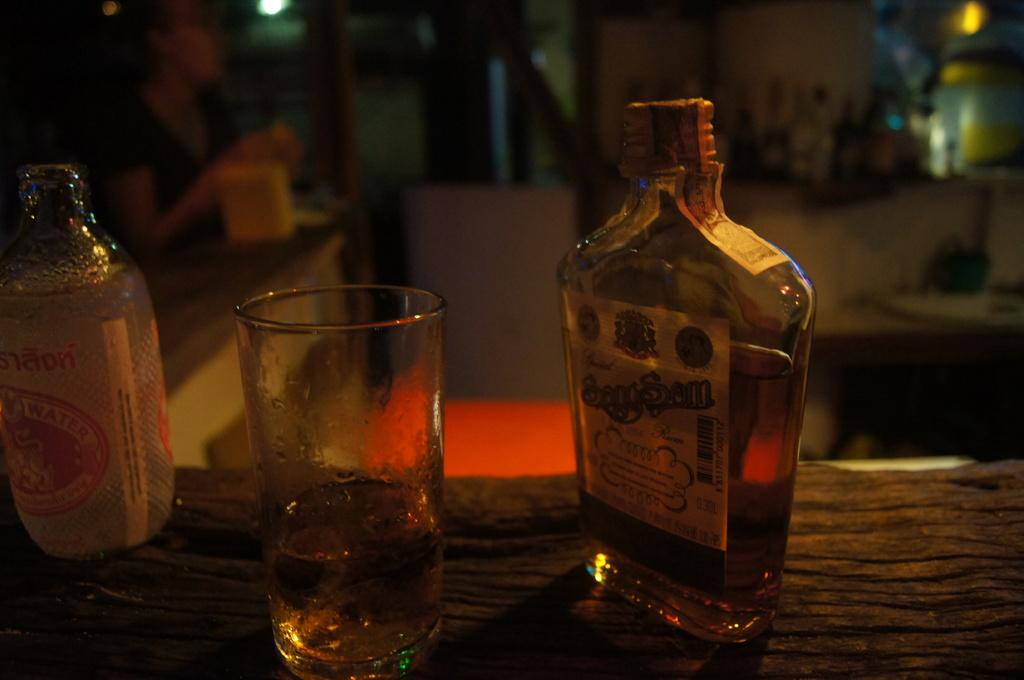<image>
Describe the image concisely. A bottle of rum sits next to an almost empty glass. 